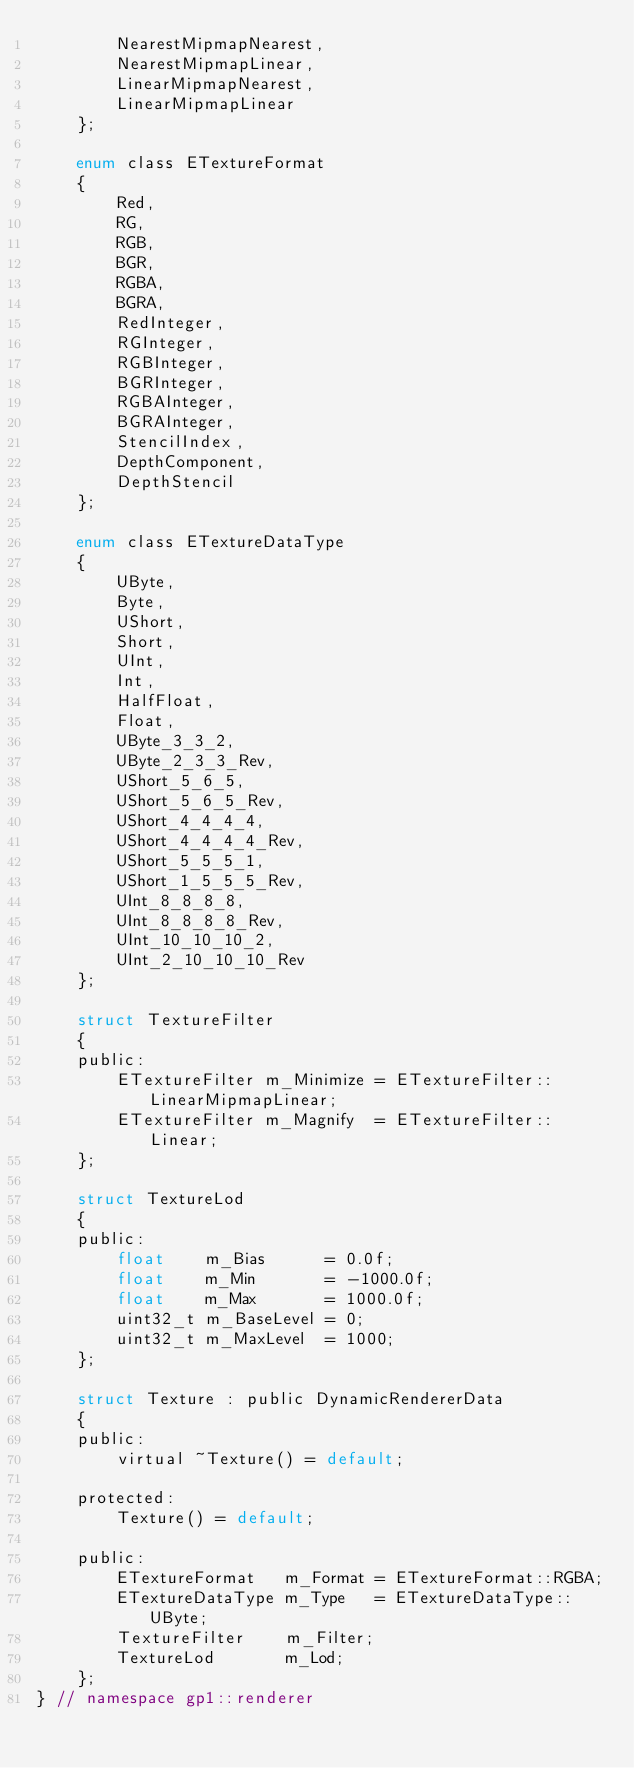<code> <loc_0><loc_0><loc_500><loc_500><_C_>		NearestMipmapNearest,
		NearestMipmapLinear,
		LinearMipmapNearest,
		LinearMipmapLinear
	};

	enum class ETextureFormat
	{
		Red,
		RG,
		RGB,
		BGR,
		RGBA,
		BGRA,
		RedInteger,
		RGInteger,
		RGBInteger,
		BGRInteger,
		RGBAInteger,
		BGRAInteger,
		StencilIndex,
		DepthComponent,
		DepthStencil
	};

	enum class ETextureDataType
	{
		UByte,
		Byte,
		UShort,
		Short,
		UInt,
		Int,
		HalfFloat,
		Float,
		UByte_3_3_2,
		UByte_2_3_3_Rev,
		UShort_5_6_5,
		UShort_5_6_5_Rev,
		UShort_4_4_4_4,
		UShort_4_4_4_4_Rev,
		UShort_5_5_5_1,
		UShort_1_5_5_5_Rev,
		UInt_8_8_8_8,
		UInt_8_8_8_8_Rev,
		UInt_10_10_10_2,
		UInt_2_10_10_10_Rev
	};

	struct TextureFilter
	{
	public:
		ETextureFilter m_Minimize = ETextureFilter::LinearMipmapLinear;
		ETextureFilter m_Magnify  = ETextureFilter::Linear;
	};

	struct TextureLod
	{
	public:
		float    m_Bias      = 0.0f;
		float    m_Min       = -1000.0f;
		float    m_Max       = 1000.0f;
		uint32_t m_BaseLevel = 0;
		uint32_t m_MaxLevel  = 1000;
	};

	struct Texture : public DynamicRendererData
	{
	public:
		virtual ~Texture() = default;

	protected:
		Texture() = default;

	public:
		ETextureFormat   m_Format = ETextureFormat::RGBA;
		ETextureDataType m_Type   = ETextureDataType::UByte;
		TextureFilter    m_Filter;
		TextureLod       m_Lod;
	};
} // namespace gp1::renderer</code> 